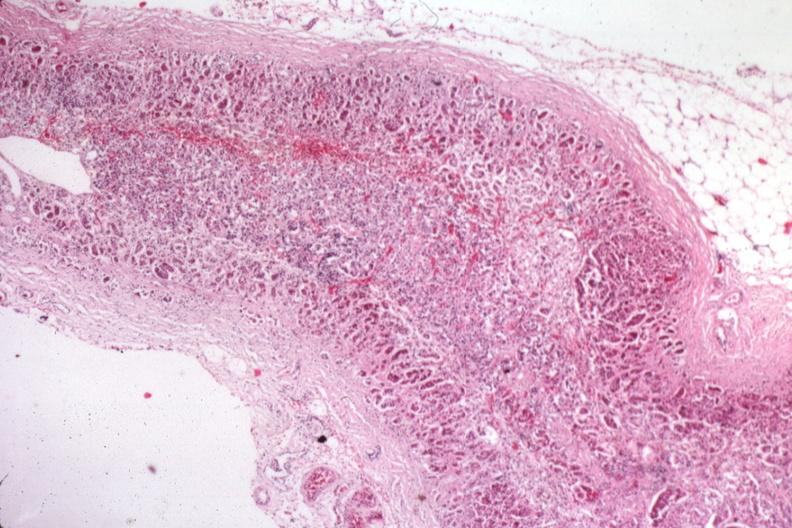what is present?
Answer the question using a single word or phrase. Adrenal 